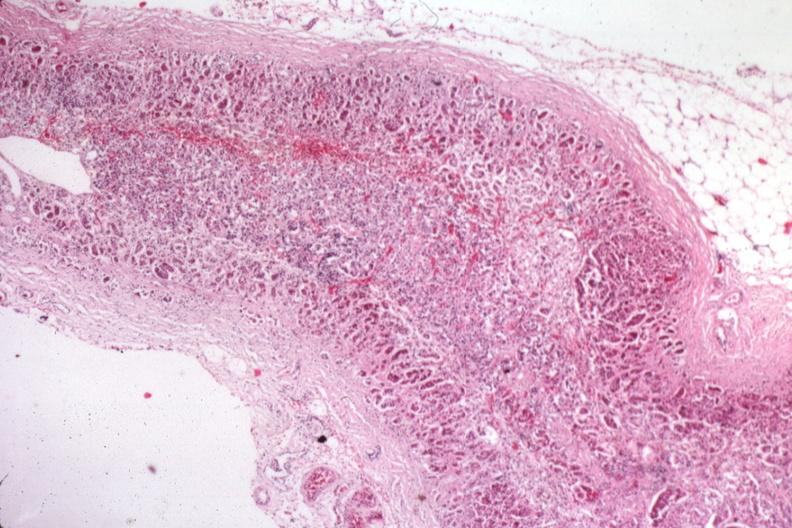what is present?
Answer the question using a single word or phrase. Adrenal 